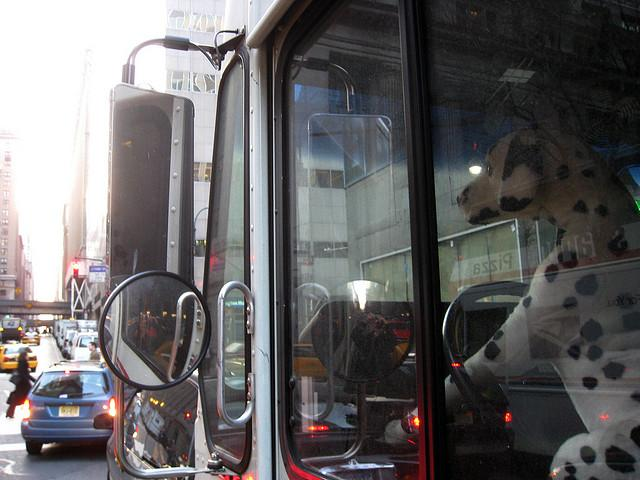Which lens is used in bus side mirror? convex 